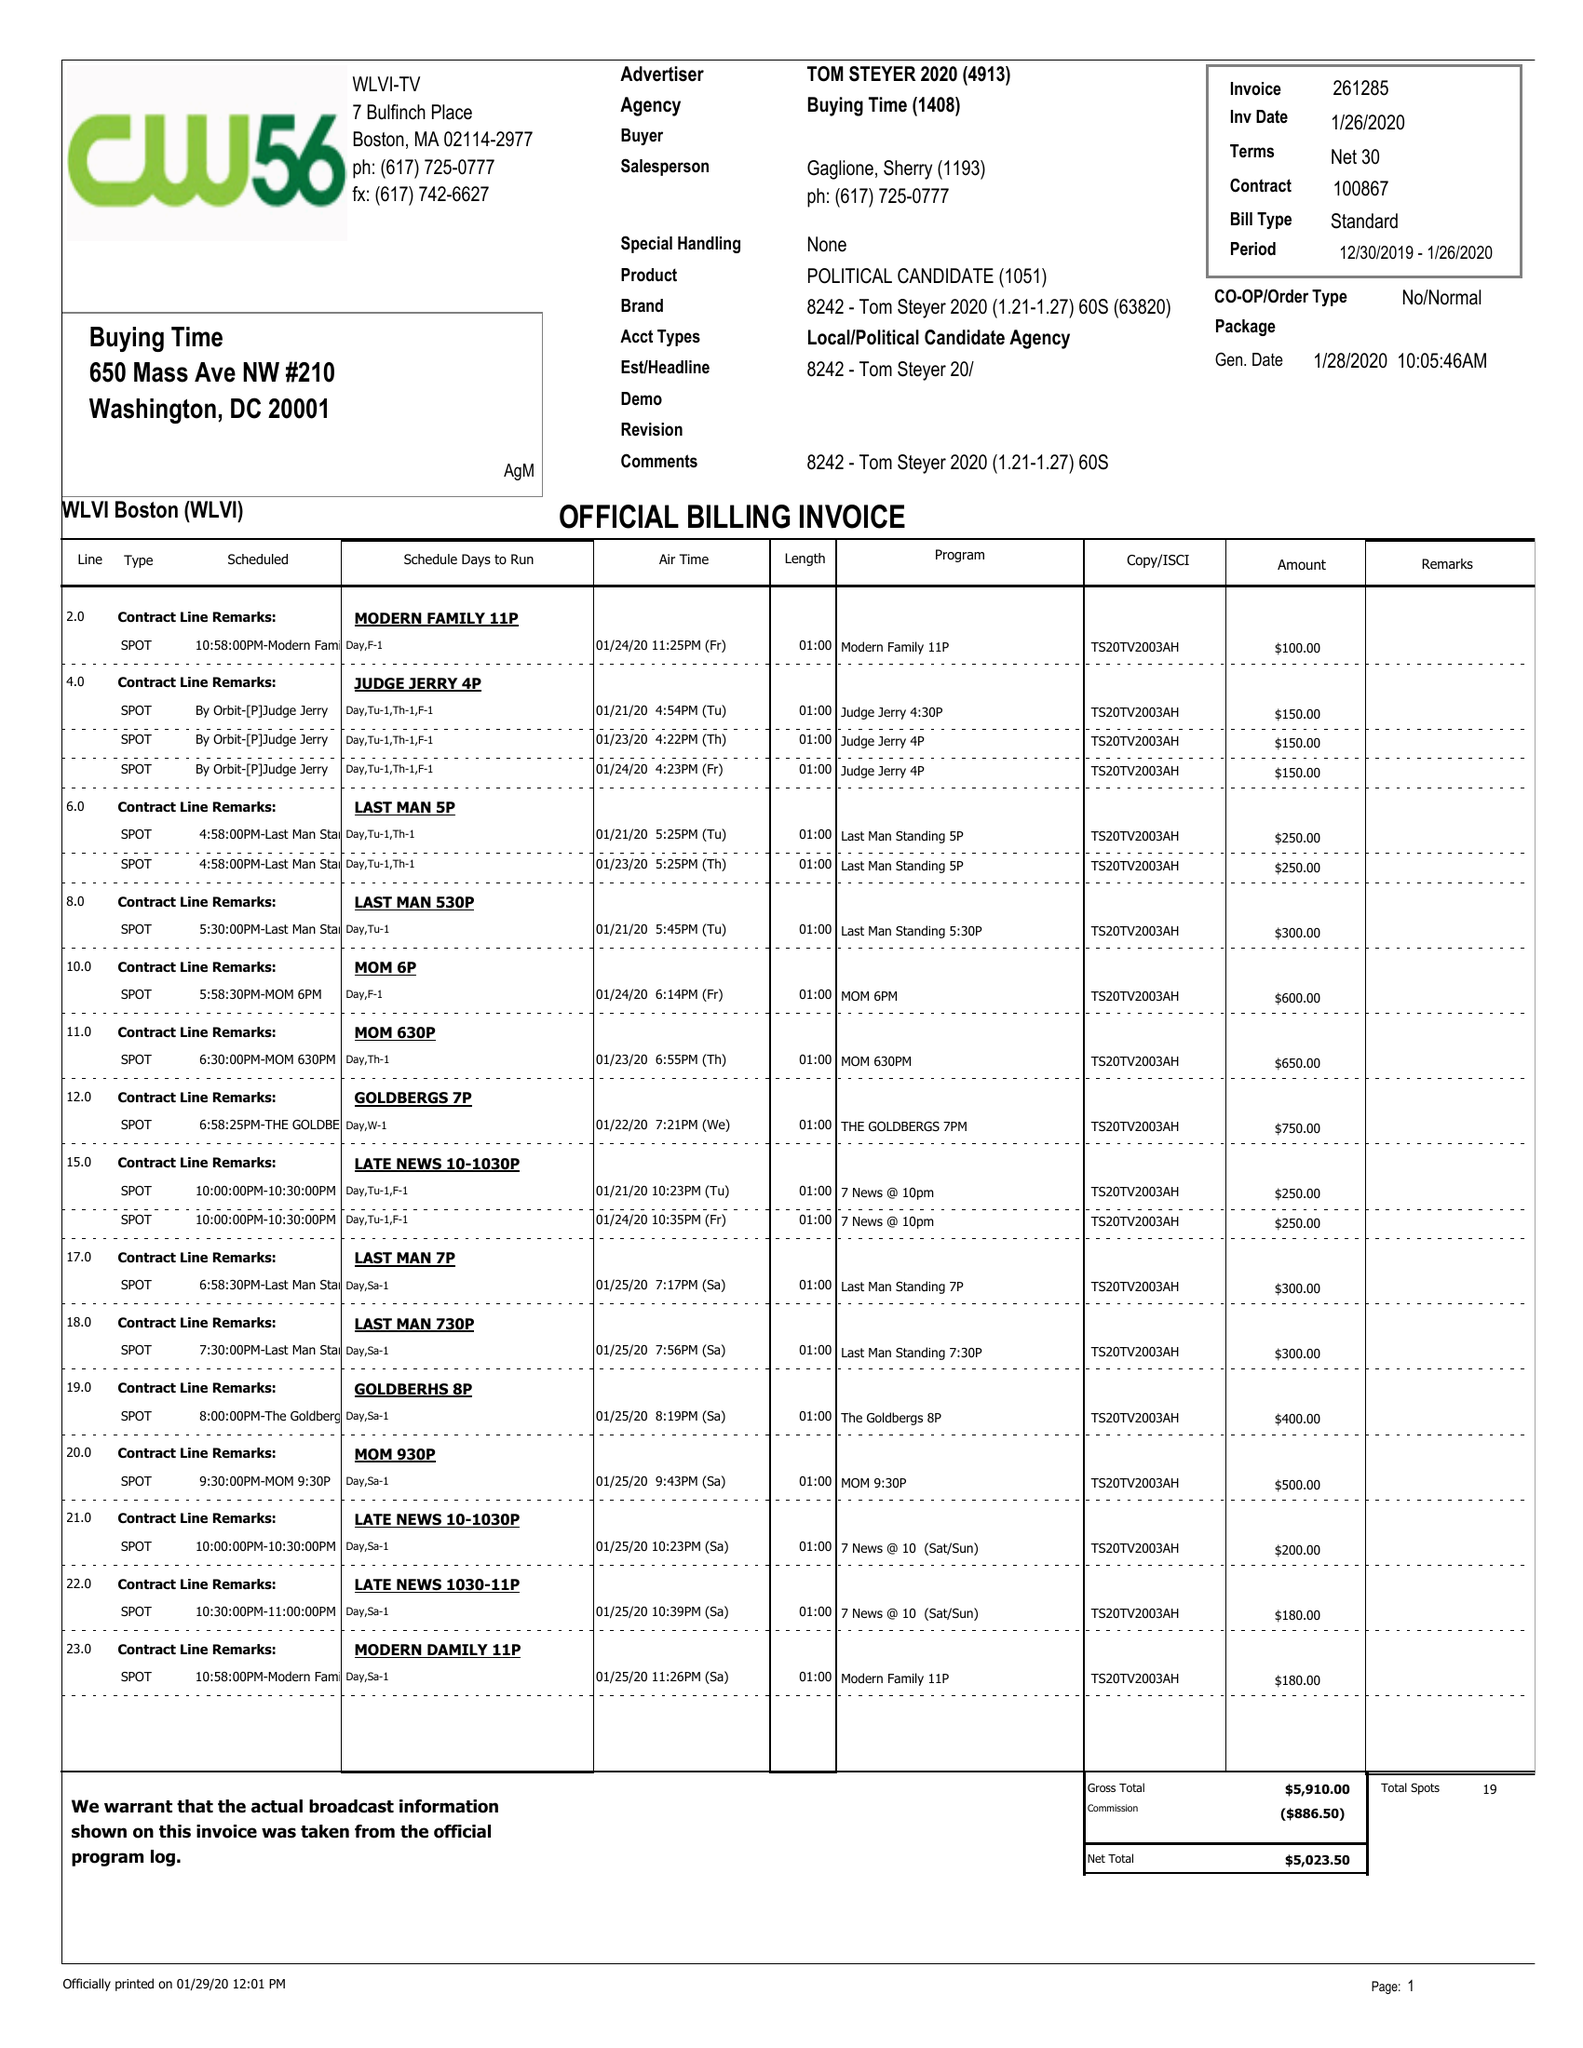What is the value for the contract_num?
Answer the question using a single word or phrase. 100867 